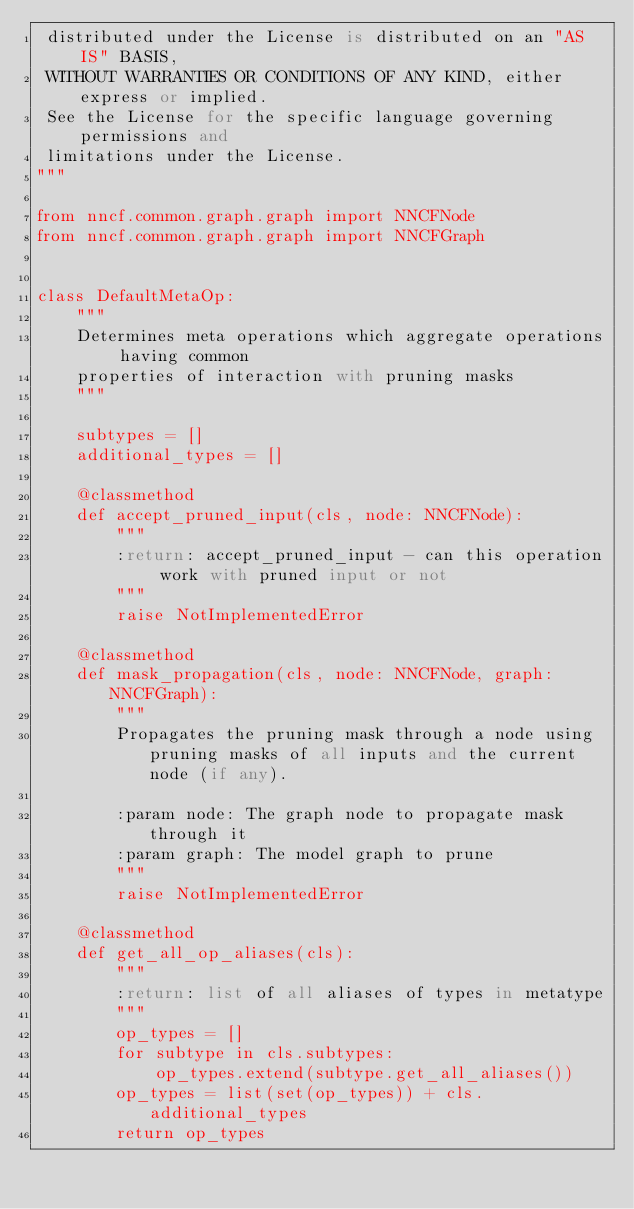<code> <loc_0><loc_0><loc_500><loc_500><_Python_> distributed under the License is distributed on an "AS IS" BASIS,
 WITHOUT WARRANTIES OR CONDITIONS OF ANY KIND, either express or implied.
 See the License for the specific language governing permissions and
 limitations under the License.
"""

from nncf.common.graph.graph import NNCFNode
from nncf.common.graph.graph import NNCFGraph


class DefaultMetaOp:
    """
    Determines meta operations which aggregate operations having common
    properties of interaction with pruning masks
    """

    subtypes = []
    additional_types = []

    @classmethod
    def accept_pruned_input(cls, node: NNCFNode):
        """
        :return: accept_pruned_input - can this operation work with pruned input or not
        """
        raise NotImplementedError

    @classmethod
    def mask_propagation(cls, node: NNCFNode, graph: NNCFGraph):
        """
        Propagates the pruning mask through a node using pruning masks of all inputs and the current node (if any).

        :param node: The graph node to propagate mask through it
        :param graph: The model graph to prune
        """
        raise NotImplementedError

    @classmethod
    def get_all_op_aliases(cls):
        """
        :return: list of all aliases of types in metatype
        """
        op_types = []
        for subtype in cls.subtypes:
            op_types.extend(subtype.get_all_aliases())
        op_types = list(set(op_types)) + cls.additional_types
        return op_types
</code> 